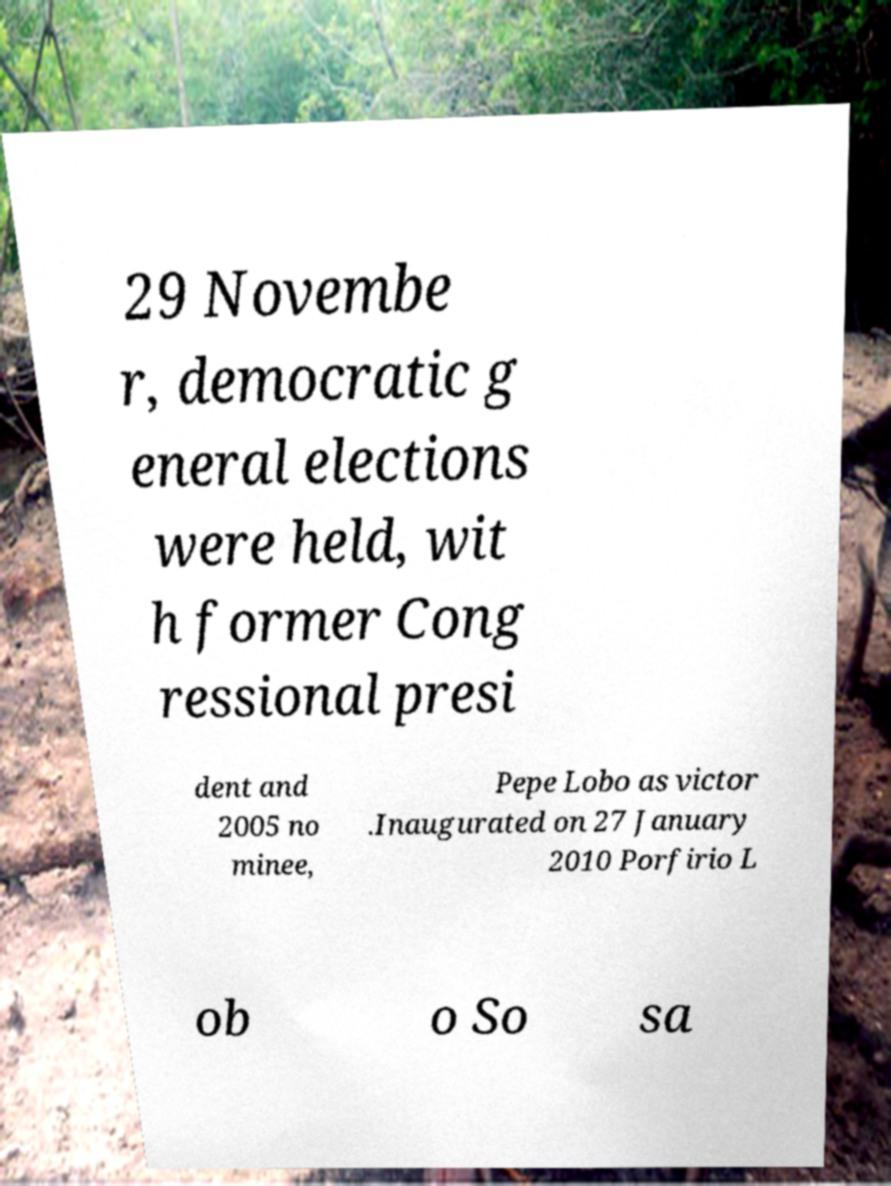Can you read and provide the text displayed in the image?This photo seems to have some interesting text. Can you extract and type it out for me? 29 Novembe r, democratic g eneral elections were held, wit h former Cong ressional presi dent and 2005 no minee, Pepe Lobo as victor .Inaugurated on 27 January 2010 Porfirio L ob o So sa 